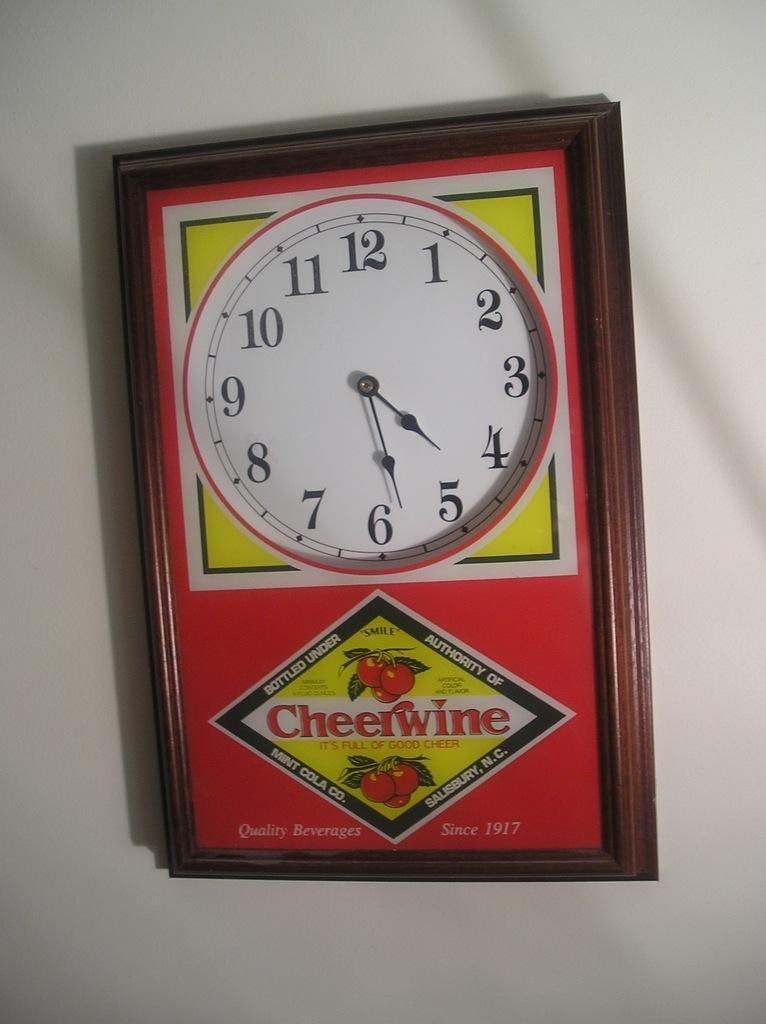<image>
Summarize the visual content of the image. A wall clock with a Cheerwine advertisement showing the time is 4:28. 